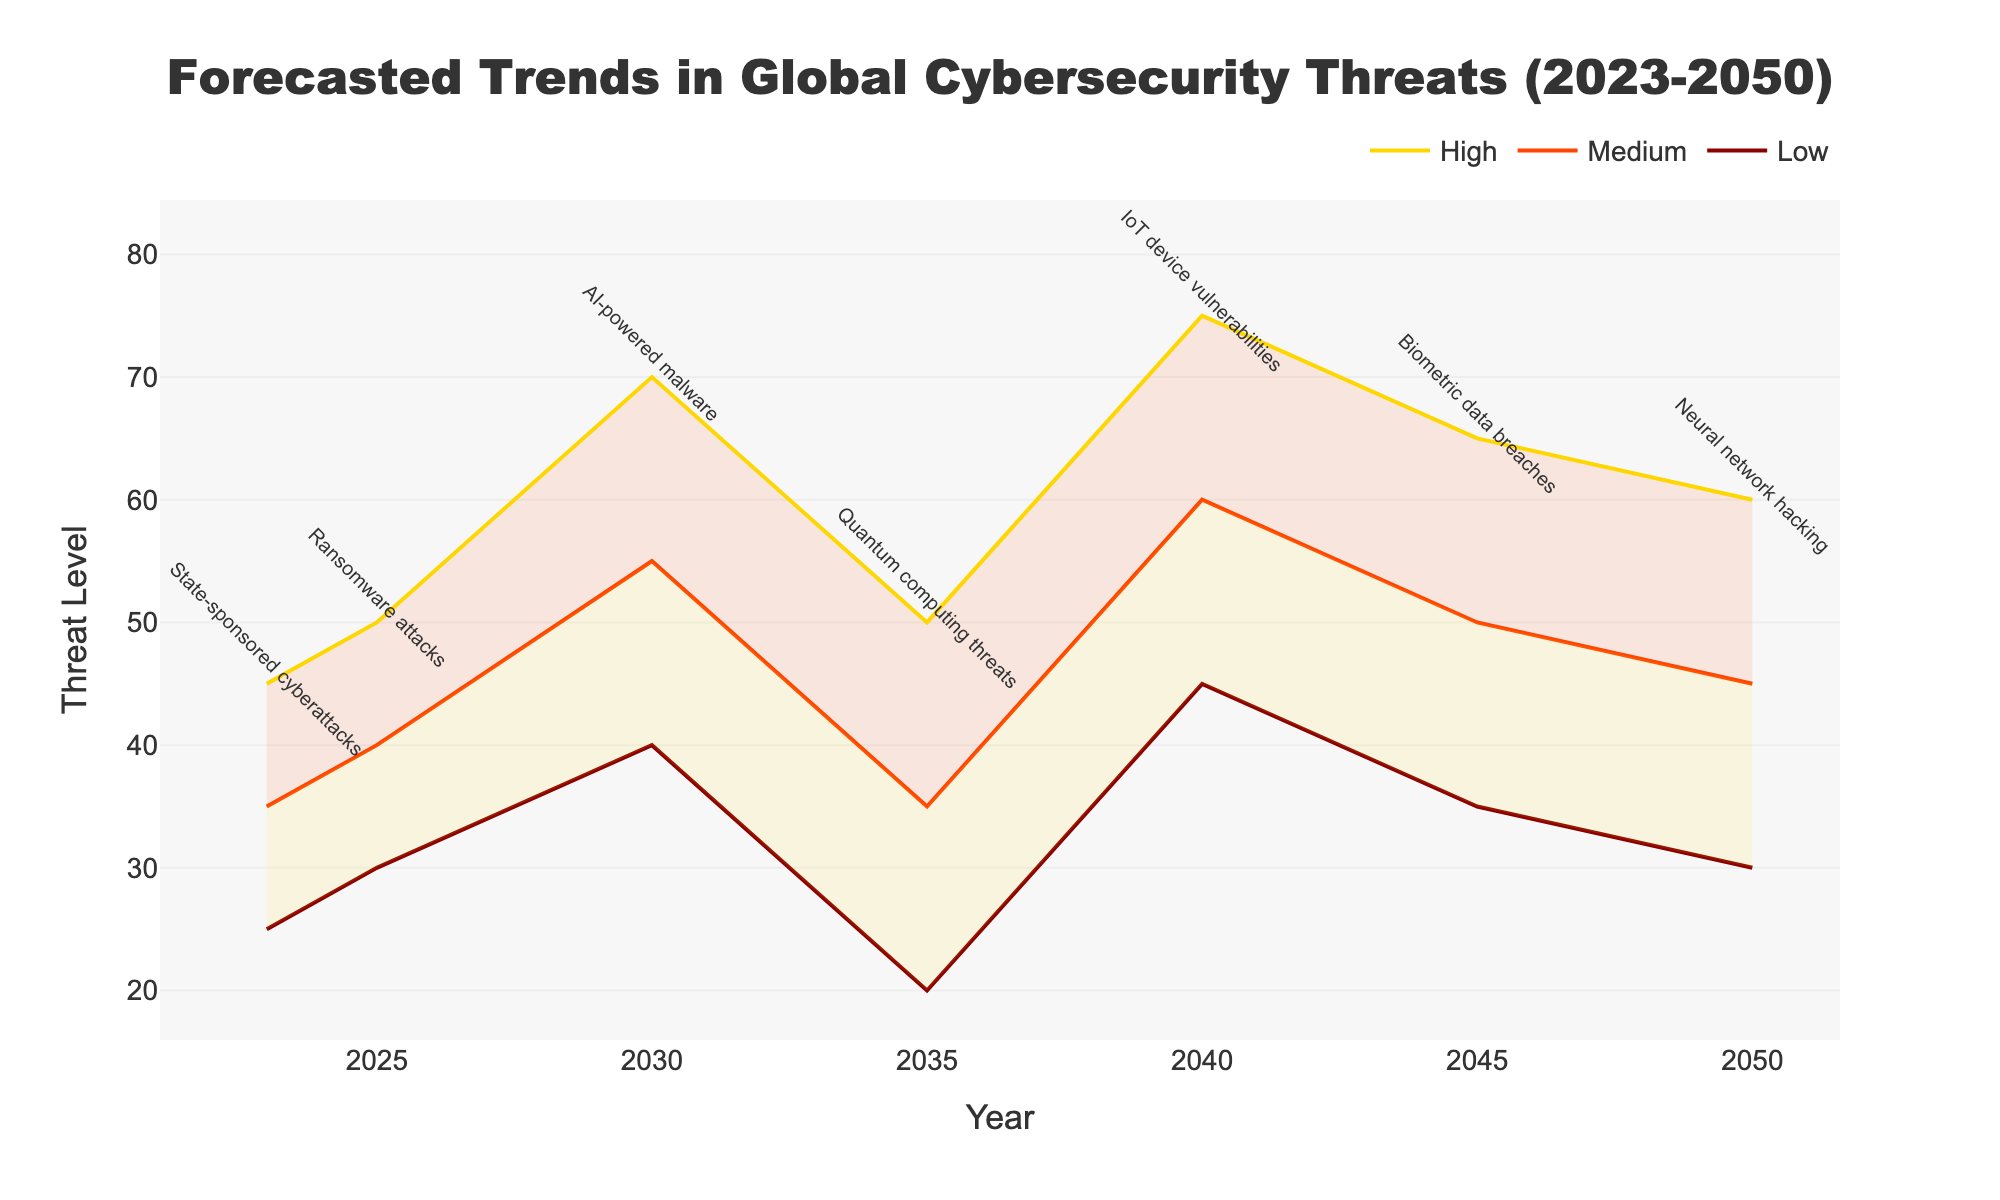What is the title of the figure? The title is displayed at the top of the figure. Reading the title directly from there gives the result.
Answer: Forecasted Trends in Global Cybersecurity Threats (2023-2050) What are the colors used for the different threat levels? The colors of the lines can be distinguished visually. The dark red represents the Low threat level, the orange-red represents the Medium threat level, and the gold represents the High threat level.
Answer: Dark red, Orange-red, Gold Which type of cybersecurity threat is projected to have the highest level in 2040? By examining the plot annotations at the year 2040, we see the label "IoT device vulnerabilities." The plot shows that IoT device vulnerabilities have the highest threat level in 2040 across all metrics (Low, Medium, High).
Answer: IoT device vulnerabilities How does the level of AI-powered malware change from 2023 to 2030 for the Medium threat level? The Medium threat level line for AI-powered malware needs to be checked. From the data, AI-powered malware in 2030 at the Medium level is projected at 55, while the start year 2023 does not include AI-powered malware. Comparing these, AI-powered malware appears to increase.
Answer: Increase to 55 Which threat has the closest levels for the Medium and High predictions in 2035? From the plot, we look at the values for the year 2035 and compare the Medium and High predictions. The Quantum computing threats in 2035 are Medium (35) and High (50). Other threats have more significant differences.
Answer: Quantum computing threats What year is associated with the highest High threat level for Ransomware attacks? To find this, look at the plot annotations and the threat levels for ransomware attacks. The highest level for ransomware attacks is 50 in 2025.
Answer: 2025 Compare the Low threat level of State-sponsored cyberattacks in 2023 with the Low threat level of Biometric data breaches in 2045. Which is higher? Examine the plot's Low lines and annotations for the specified years. In 2023, State-sponsored cyberattacks' low level is 25, and in 2045, Biometric data breaches' low level is 35.
Answer: Biometric data breaches What is the average High threat level for the years 2040 and 2045 for IoT device vulnerabilities and Biometric data breaches respectively? From the plot, check the High levels for IoT device vulnerabilities in 2040 (75) and Biometric data breaches in 2045 (65). Calculate the average: (75 + 65) / 2.
Answer: 70 Which threat is projected to emerge around the year 2035 and grow significantly by 2050? By looking at the projected threats beginning or significantly increasing around 2035, we observe Quantum computing threats starting around 2030, but Neural network hacking appears as new in 2050.
Answer: Neural network hacking 